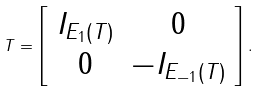Convert formula to latex. <formula><loc_0><loc_0><loc_500><loc_500>T = \left [ \begin{array} { c c } I _ { E _ { 1 } ( T ) } & 0 \\ 0 & - I _ { E _ { - 1 } ( T ) } \\ \end{array} \right ] .</formula> 